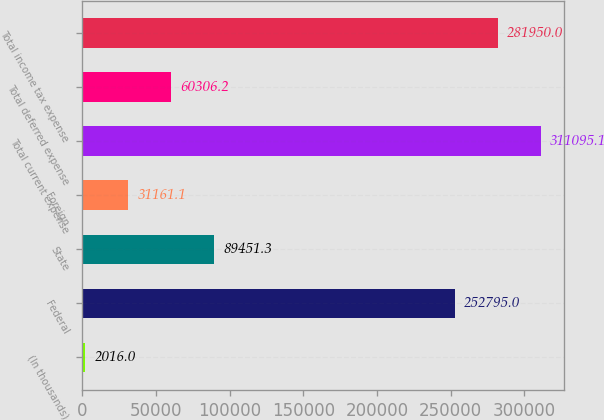Convert chart. <chart><loc_0><loc_0><loc_500><loc_500><bar_chart><fcel>(In thousands)<fcel>Federal<fcel>State<fcel>Foreign<fcel>Total current expense<fcel>Total deferred expense<fcel>Total income tax expense<nl><fcel>2016<fcel>252795<fcel>89451.3<fcel>31161.1<fcel>311095<fcel>60306.2<fcel>281950<nl></chart> 